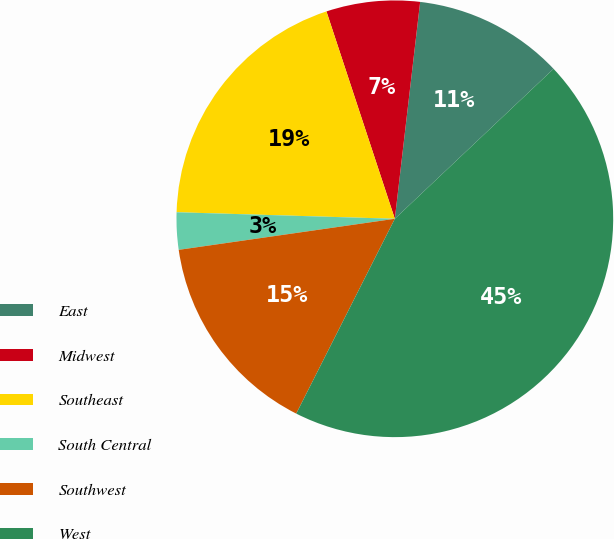Convert chart. <chart><loc_0><loc_0><loc_500><loc_500><pie_chart><fcel>East<fcel>Midwest<fcel>Southeast<fcel>South Central<fcel>Southwest<fcel>West<nl><fcel>11.1%<fcel>6.92%<fcel>19.45%<fcel>2.75%<fcel>15.27%<fcel>44.5%<nl></chart> 